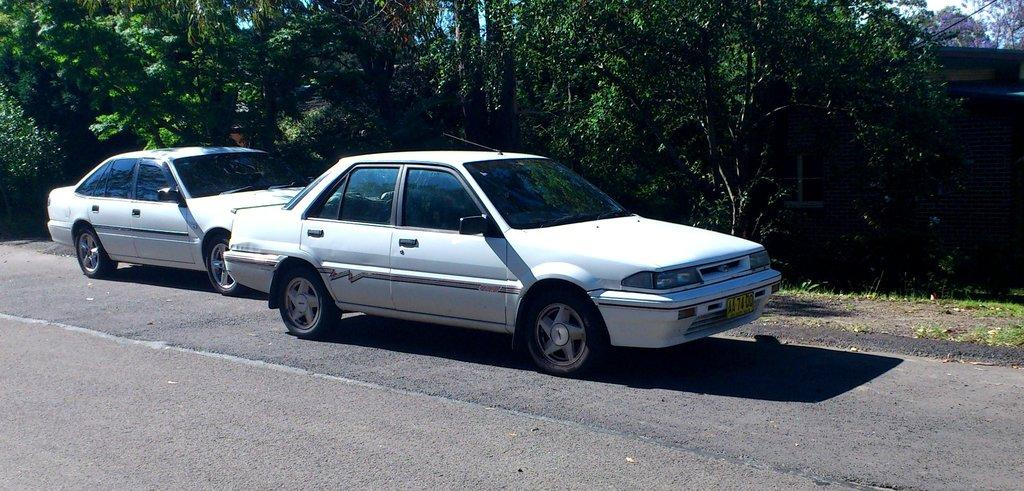How many cars are in the image? There are two white color cars in the image. Where are the cars located in the image? The cars are parked on the side of the road. What can be seen in the background of the image? There are trees and wires visible in the background of the image. Can you see any fangs on the cars in the image? There are no fangs present on the cars in the image, as cars do not have fangs. 